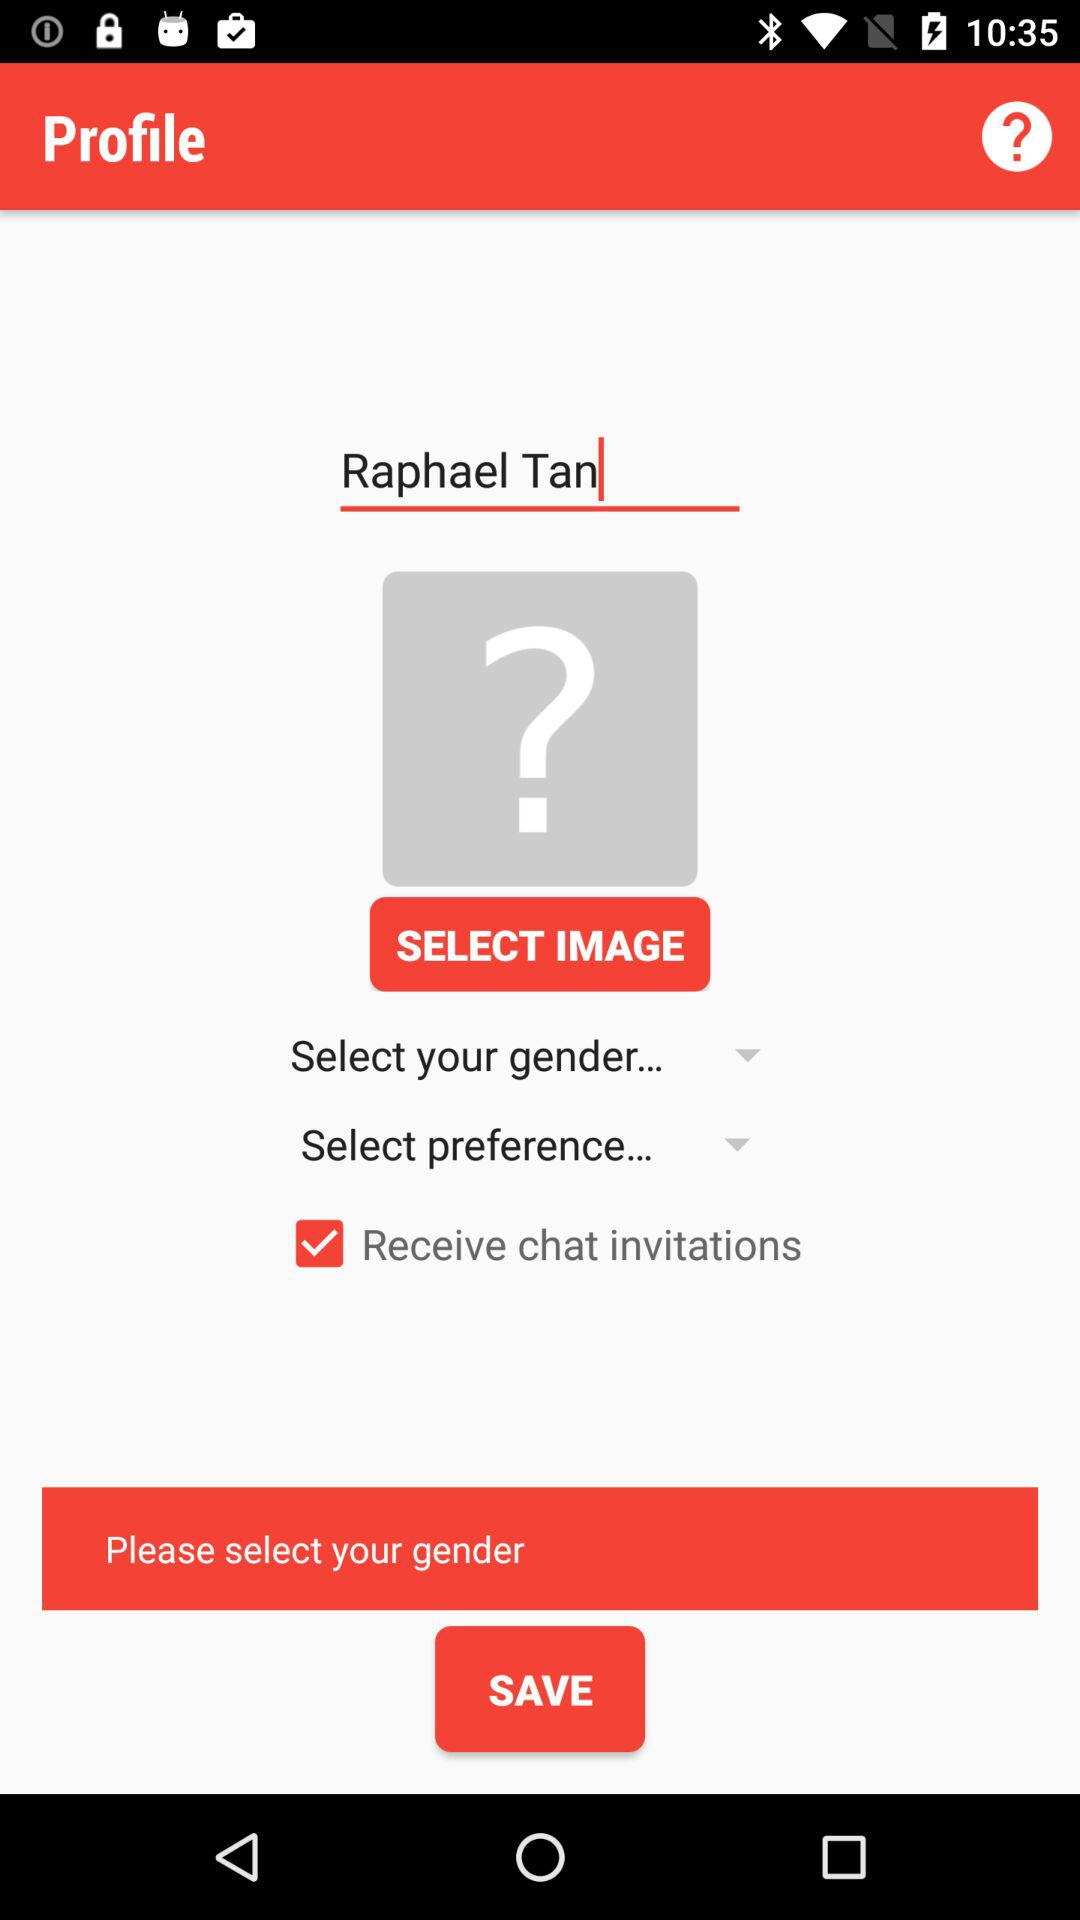What is the given profile name? The given profile name is Raphael Tan. 